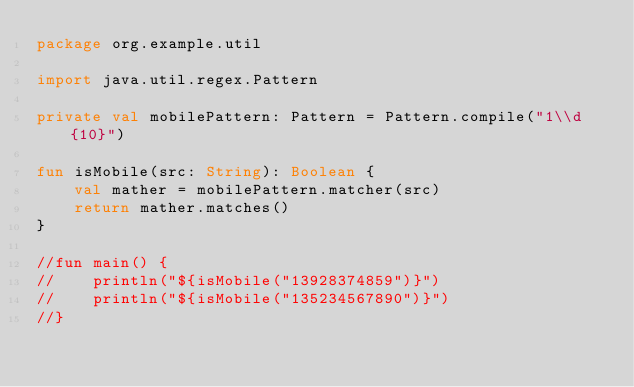<code> <loc_0><loc_0><loc_500><loc_500><_Kotlin_>package org.example.util

import java.util.regex.Pattern

private val mobilePattern: Pattern = Pattern.compile("1\\d{10}")

fun isMobile(src: String): Boolean {
    val mather = mobilePattern.matcher(src)
    return mather.matches()
}

//fun main() {
//    println("${isMobile("13928374859")}")
//    println("${isMobile("135234567890")}")
//}</code> 